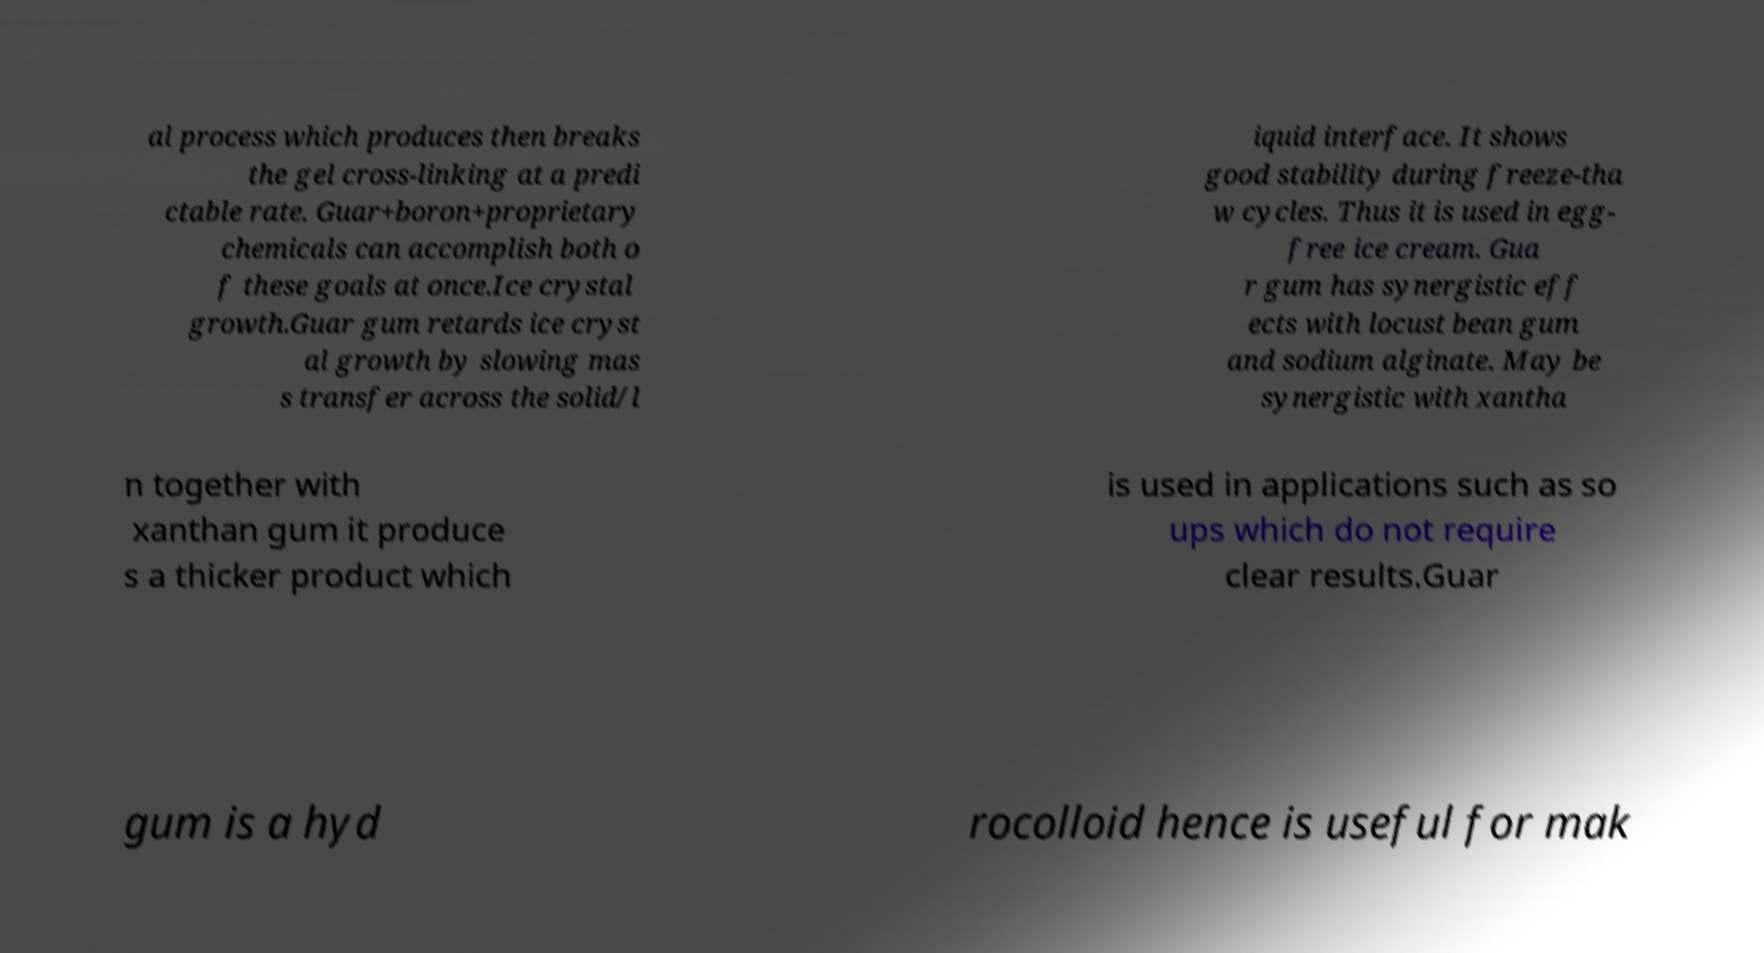Please identify and transcribe the text found in this image. al process which produces then breaks the gel cross-linking at a predi ctable rate. Guar+boron+proprietary chemicals can accomplish both o f these goals at once.Ice crystal growth.Guar gum retards ice cryst al growth by slowing mas s transfer across the solid/l iquid interface. It shows good stability during freeze-tha w cycles. Thus it is used in egg- free ice cream. Gua r gum has synergistic eff ects with locust bean gum and sodium alginate. May be synergistic with xantha n together with xanthan gum it produce s a thicker product which is used in applications such as so ups which do not require clear results.Guar gum is a hyd rocolloid hence is useful for mak 